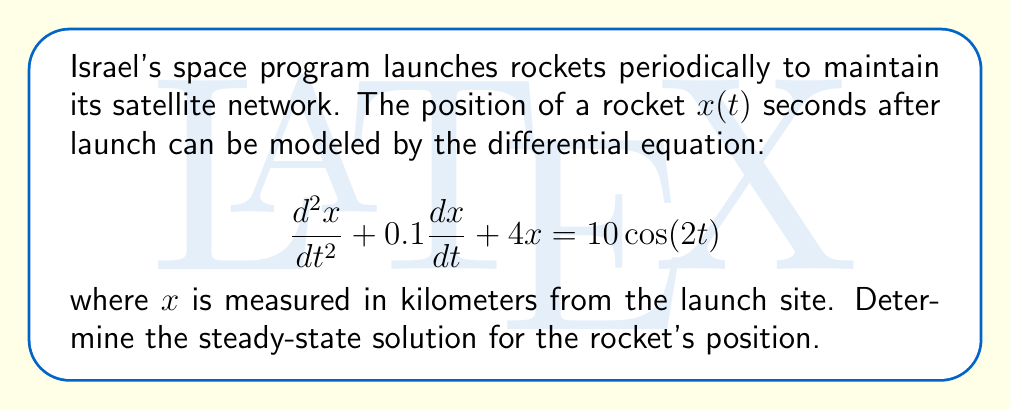Can you answer this question? To find the steady-state solution, we follow these steps:

1) The steady-state solution will have the same frequency as the forcing function, so we assume a solution of the form:
   $$x(t) = A\cos(2t) + B\sin(2t)$$

2) We need to find $A$ and $B$. First, let's calculate the derivatives:
   $$\frac{dx}{dt} = -2A\sin(2t) + 2B\cos(2t)$$
   $$\frac{d^2x}{dt^2} = -4A\cos(2t) - 4B\sin(2t)$$

3) Substitute these into the original differential equation:
   $$(-4A\cos(2t) - 4B\sin(2t)) + 0.1(-2A\sin(2t) + 2B\cos(2t)) + 4(A\cos(2t) + B\sin(2t)) = 10\cos(2t)$$

4) Collect terms with $\cos(2t)$ and $\sin(2t)$:
   $$(-4A + 0.2B + 4A)\cos(2t) + (-4B - 0.2A + 4B)\sin(2t) = 10\cos(2t)$$

5) Equate coefficients:
   $$0.2B = 10$$
   $$-0.2A = 0$$

6) Solve these equations:
   $$B = 50$$
   $$A = 0$$

7) Therefore, the steady-state solution is:
   $$x(t) = 50\sin(2t)$$
Answer: $x(t) = 50\sin(2t)$ 